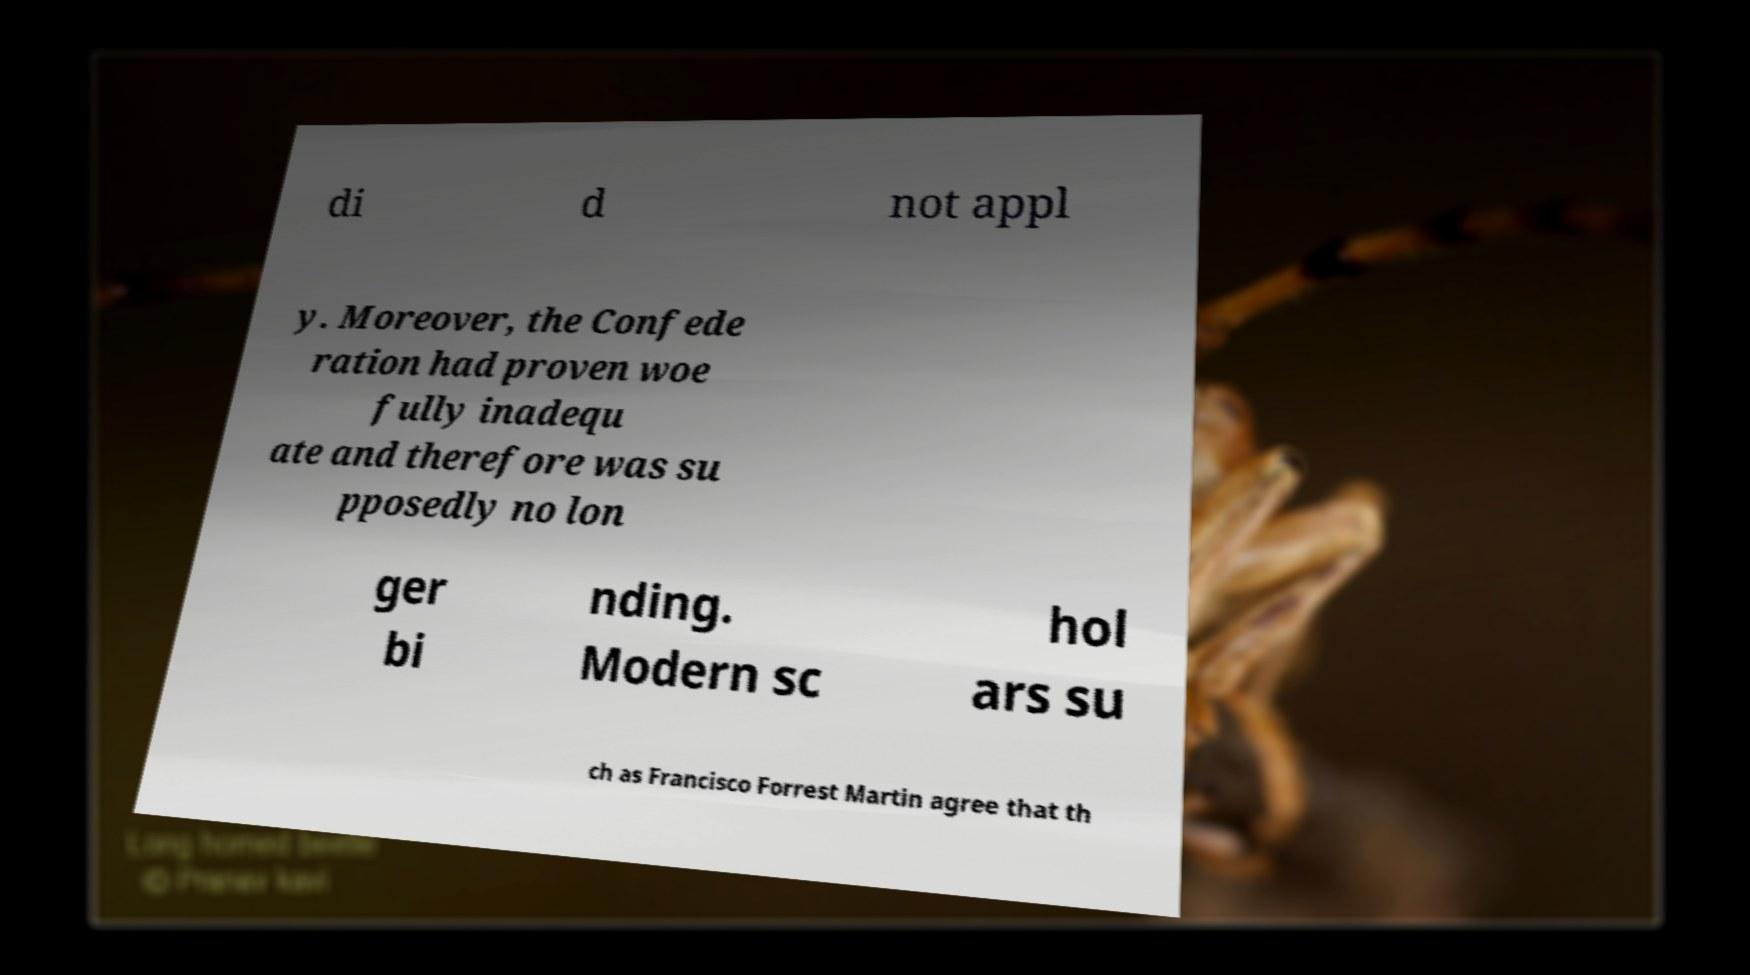Could you extract and type out the text from this image? di d not appl y. Moreover, the Confede ration had proven woe fully inadequ ate and therefore was su pposedly no lon ger bi nding. Modern sc hol ars su ch as Francisco Forrest Martin agree that th 